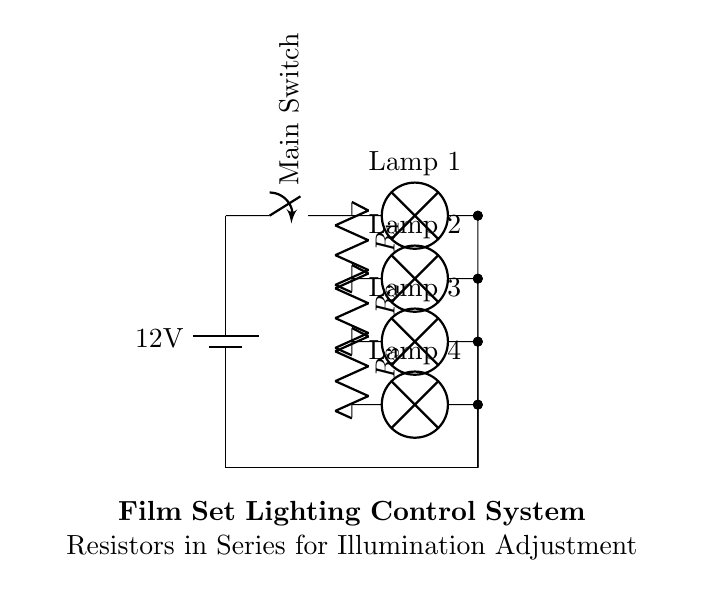What is the voltage of the power source? The voltage of the power source is indicated on the battery symbol. It shows a value of 12 volts.
Answer: 12 volts How many resistors are in the circuit? The circuit diagram shows three resistors labeled R1, R2, and R3 connected in series. Therefore, there are a total of three resistors present.
Answer: 3 What type of circuit is used for controlling illumination? The circuit uses a series configuration where resistors are connected one after another, which is typical for controlling brightness by adjusting total resistance.
Answer: Series circuit Which device connects the circuit to the power source? The device connecting the circuit to the power source is a switch, indicated by the switch symbol in the circuit diagram. It allows the user to turn the circuit on or off.
Answer: Switch What is the purpose of the resistors in this circuit? The resistors in this circuit are used to adjust the current flowing through the lamps, effectively controlling the brightness or illumination of each lamp in the series.
Answer: Control brightness How many lamps are connected to the resistors? The circuit diagram shows four lamps connected at different points in the series configuration, one for each resistor. Thus, there are four lamps in total.
Answer: 4 If R1 is removed, what happens to the current through the lamps? If R1 is removed, the total resistance in the circuit decreases, which increases the current flowing through the lamps. The brightness of the lamps would likely increase due to this change.
Answer: Increases 